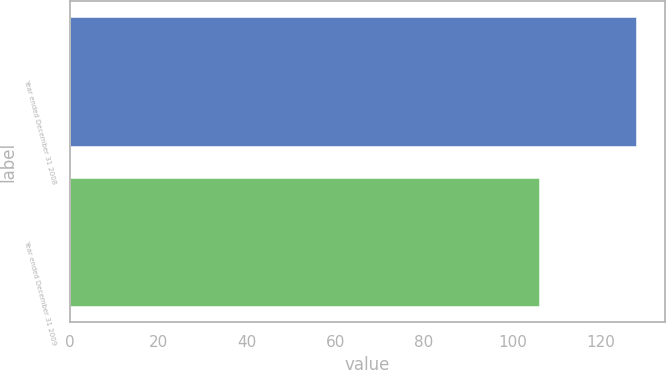Convert chart. <chart><loc_0><loc_0><loc_500><loc_500><bar_chart><fcel>Year ended December 31 2008<fcel>Year ended December 31 2009<nl><fcel>128<fcel>106<nl></chart> 